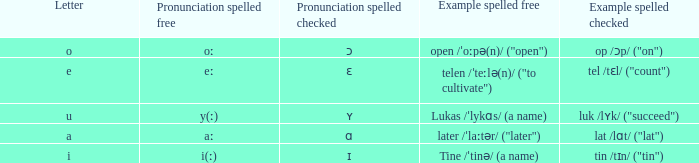What is Letter, when Example Spelled Checked is "tin /tɪn/ ("tin")"? I. 